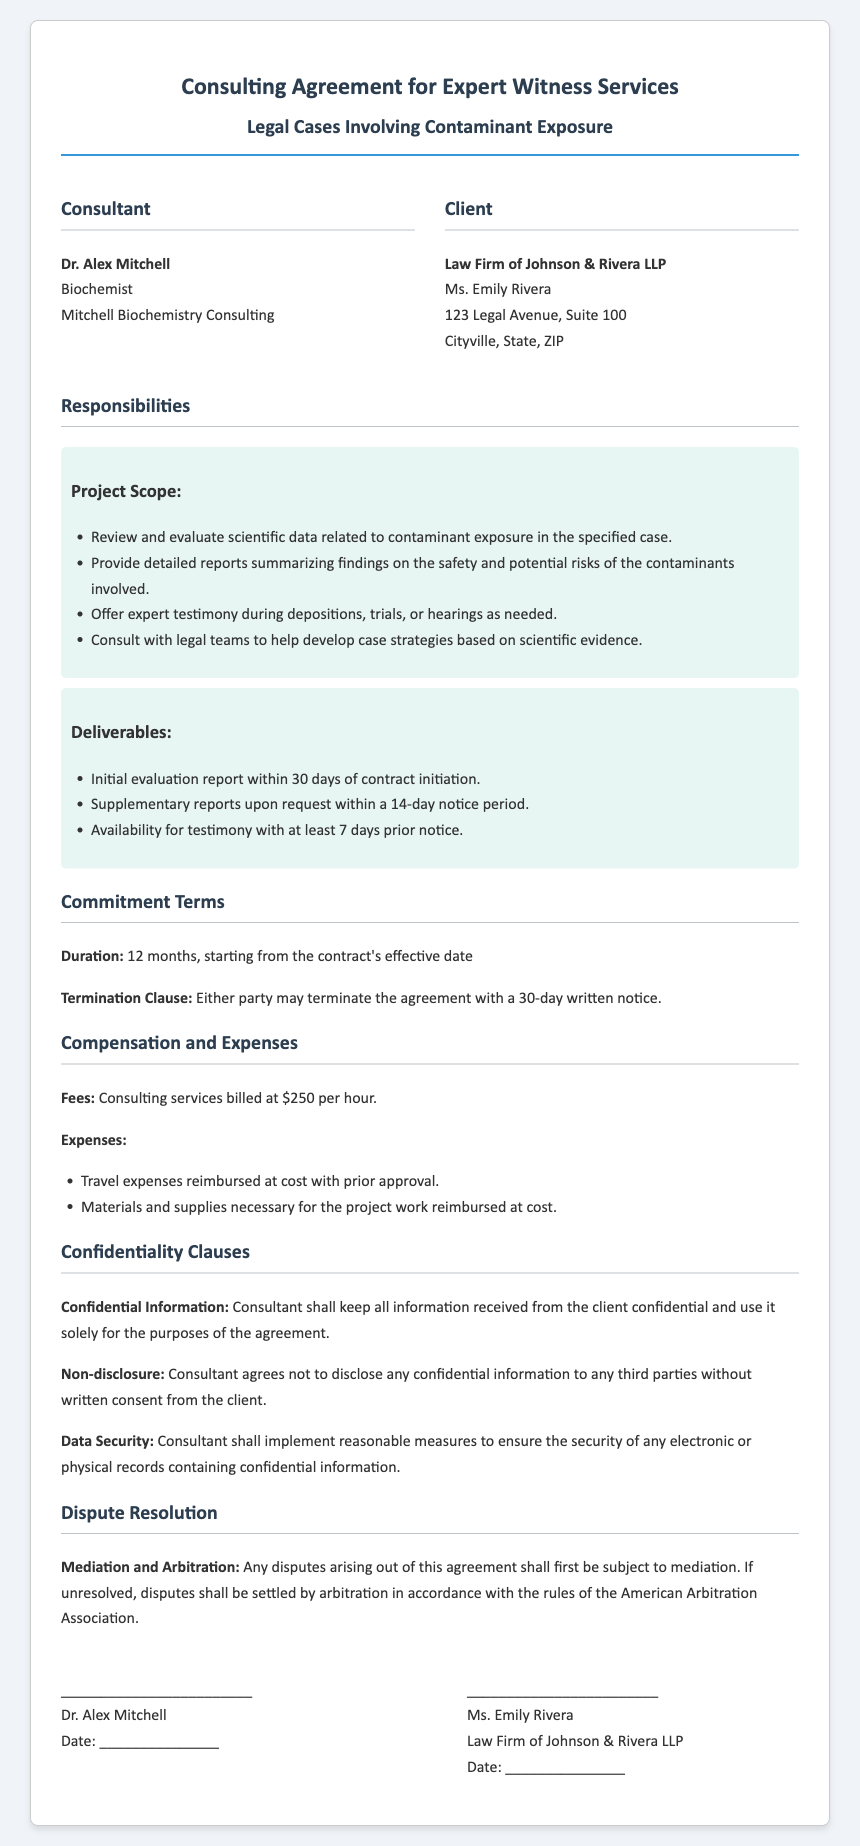What is the name of the consultant? The document states the consultant's name at the beginning under the Consultant section.
Answer: Dr. Alex Mitchell What is the term duration of the contract? The duration of the contract is explicitly mentioned in the Commitment Terms section.
Answer: 12 months What is the hourly rate for the consulting services? The fees for consulting services are specified in the Compensation and Expenses section.
Answer: $250 per hour Who is the client represented in the document? The client’s information is presented in the Client section at the top of the document.
Answer: Law Firm of Johnson & Rivera LLP What should be provided within 30 days of contract initiation? The document outlines the deliverables and the initial timeline in the Responsibilities section.
Answer: Initial evaluation report What is the required notice period for supplementary reports? This information can be found in the Deliverables subsection under Responsibilities.
Answer: 14-day notice period What type of dispute resolution method is mentioned? The mediation and arbitration process is described in the Dispute Resolution section.
Answer: Mediation and Arbitration What must the consultant do with confidential information? The obligations regarding confidential information are detailed in the Confidentiality Clauses section.
Answer: Keep all information confidential What notice period is required for termination of the agreement? This information is specified under the Commitment Terms section.
Answer: 30-day written notice 